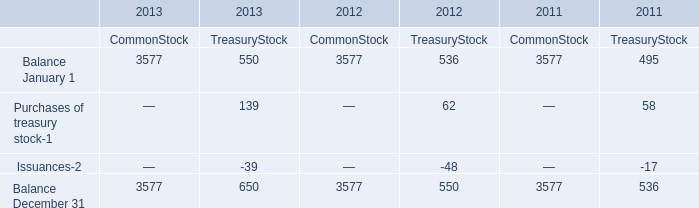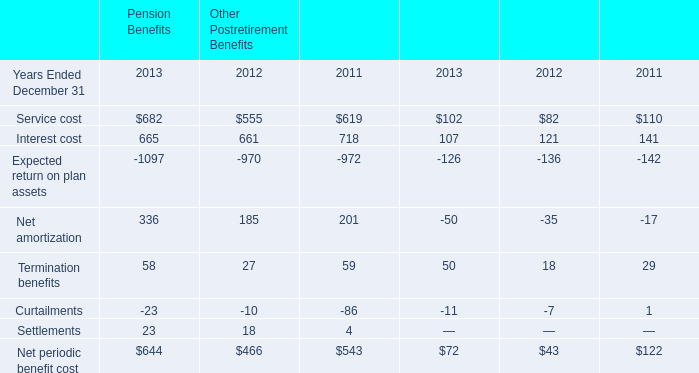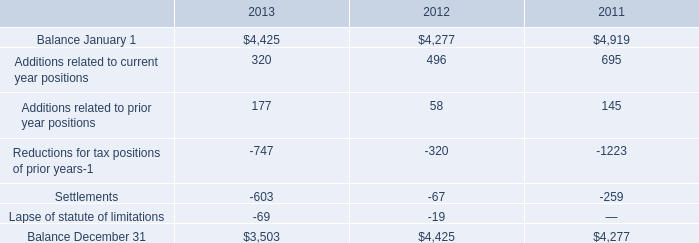What is the average amount of Balance December 31 of 2012 CommonStock, and Balance January 1 of 2012 ? 
Computations: ((3577.0 + 4277.0) / 2)
Answer: 3927.0. 